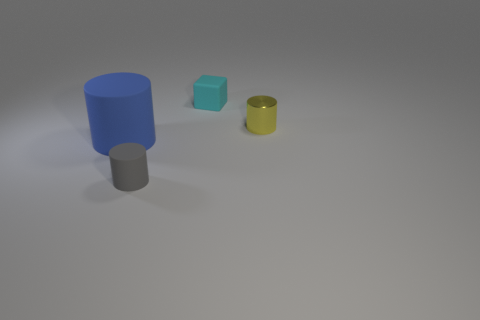Subtract all yellow cylinders. How many cylinders are left? 2 Subtract all cylinders. How many objects are left? 1 Subtract 1 cylinders. How many cylinders are left? 2 Add 1 tiny cyan cubes. How many objects exist? 5 Subtract 0 gray spheres. How many objects are left? 4 Subtract all brown cubes. Subtract all green cylinders. How many cubes are left? 1 Subtract all green blocks. How many green cylinders are left? 0 Subtract all tiny cubes. Subtract all tiny yellow things. How many objects are left? 2 Add 2 tiny matte blocks. How many tiny matte blocks are left? 3 Add 1 gray objects. How many gray objects exist? 2 